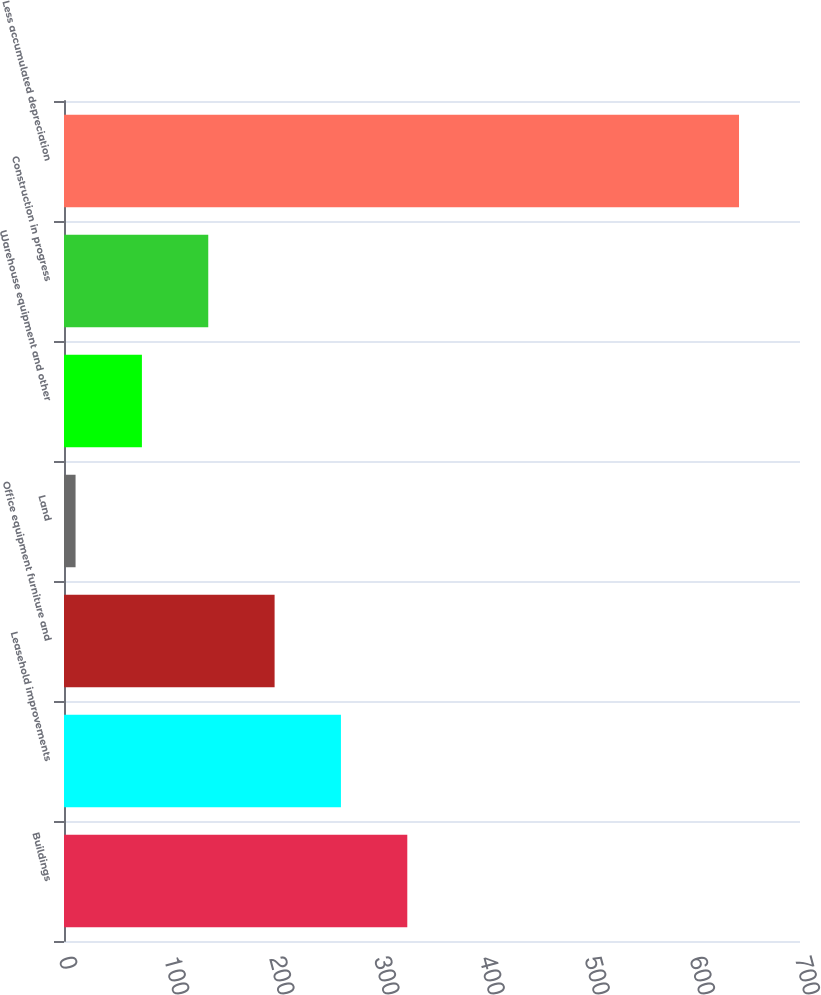<chart> <loc_0><loc_0><loc_500><loc_500><bar_chart><fcel>Buildings<fcel>Leasehold improvements<fcel>Office equipment furniture and<fcel>Land<fcel>Warehouse equipment and other<fcel>Construction in progress<fcel>Less accumulated depreciation<nl><fcel>326.5<fcel>263.4<fcel>200.3<fcel>11<fcel>74.1<fcel>137.2<fcel>642<nl></chart> 